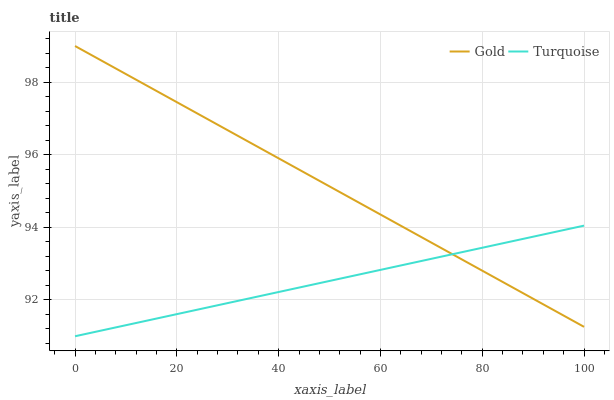Does Turquoise have the minimum area under the curve?
Answer yes or no. Yes. Does Gold have the maximum area under the curve?
Answer yes or no. Yes. Does Gold have the minimum area under the curve?
Answer yes or no. No. Is Gold the smoothest?
Answer yes or no. Yes. Is Turquoise the roughest?
Answer yes or no. Yes. Is Gold the roughest?
Answer yes or no. No. Does Turquoise have the lowest value?
Answer yes or no. Yes. Does Gold have the lowest value?
Answer yes or no. No. Does Gold have the highest value?
Answer yes or no. Yes. Does Turquoise intersect Gold?
Answer yes or no. Yes. Is Turquoise less than Gold?
Answer yes or no. No. Is Turquoise greater than Gold?
Answer yes or no. No. 